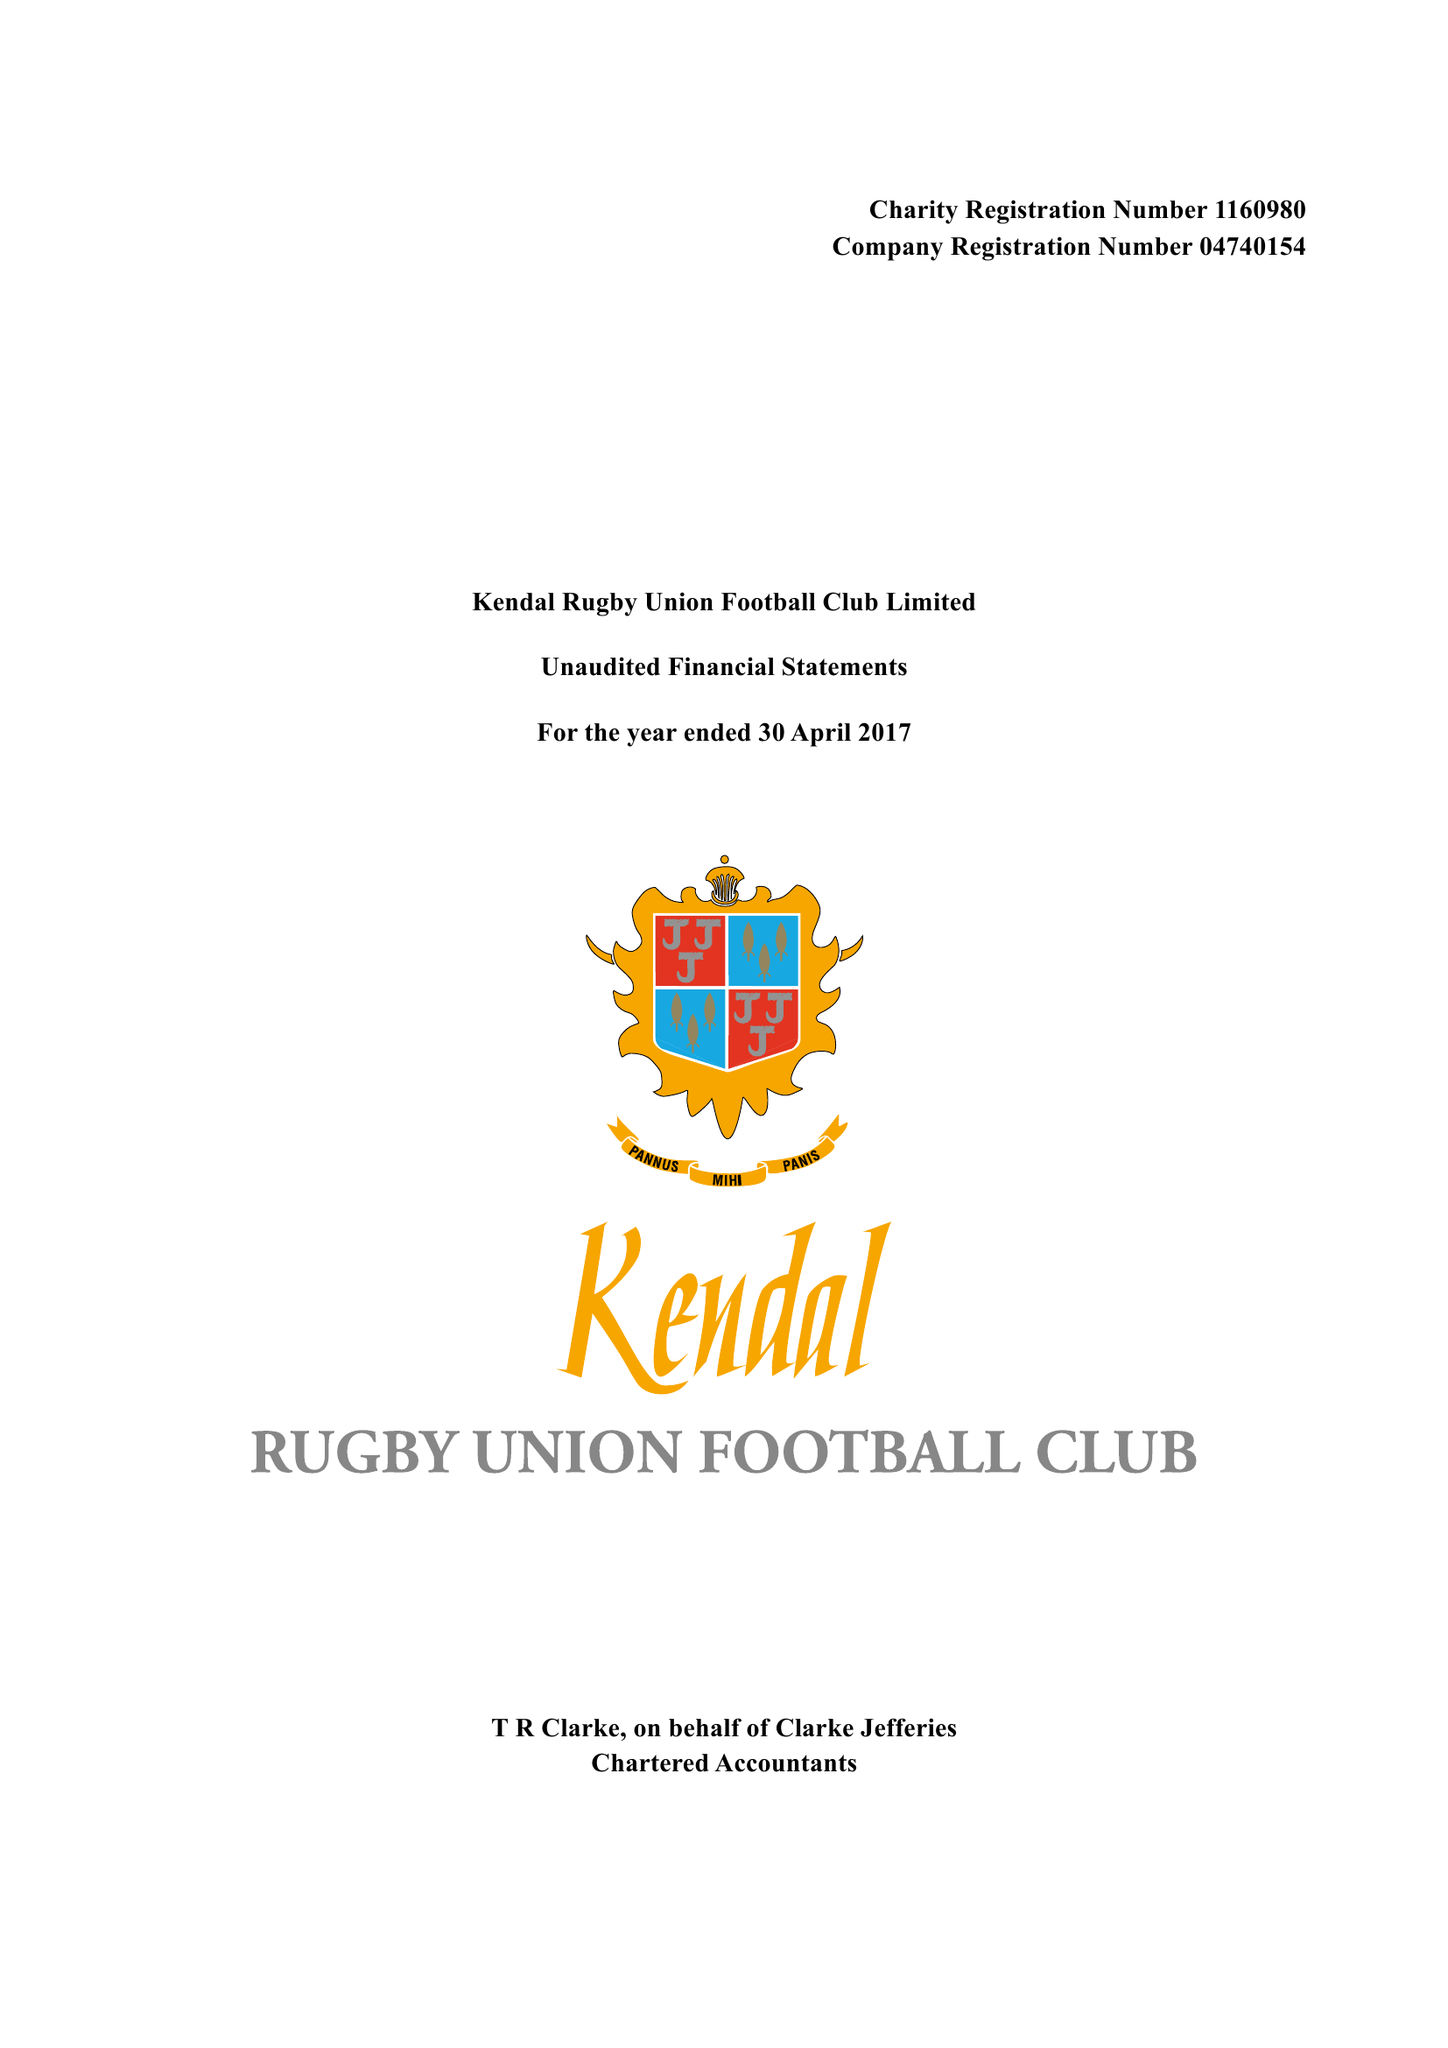What is the value for the charity_number?
Answer the question using a single word or phrase. 1160980 